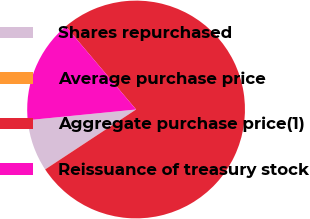<chart> <loc_0><loc_0><loc_500><loc_500><pie_chart><fcel>Shares repurchased<fcel>Average purchase price<fcel>Aggregate purchase price(1)<fcel>Reissuance of treasury stock<nl><fcel>7.7%<fcel>0.01%<fcel>76.9%<fcel>15.39%<nl></chart> 